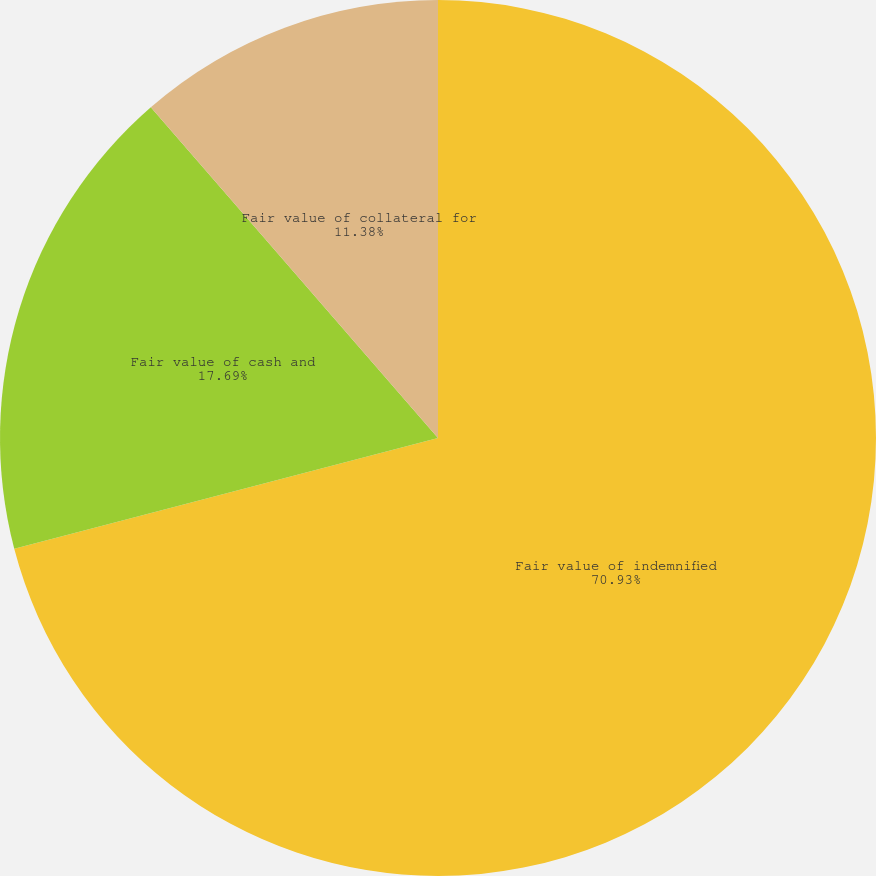<chart> <loc_0><loc_0><loc_500><loc_500><pie_chart><fcel>Fair value of indemnified<fcel>Fair value of cash and<fcel>Fair value of collateral for<nl><fcel>70.93%<fcel>17.69%<fcel>11.38%<nl></chart> 